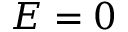<formula> <loc_0><loc_0><loc_500><loc_500>E = 0</formula> 